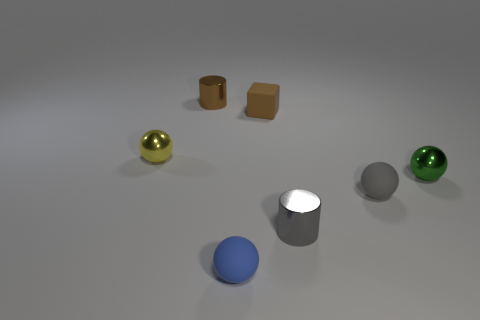Subtract all purple balls. Subtract all cyan blocks. How many balls are left? 4 Add 1 small gray objects. How many objects exist? 8 Subtract all spheres. How many objects are left? 3 Subtract all gray rubber objects. Subtract all small metallic blocks. How many objects are left? 6 Add 4 tiny gray matte spheres. How many tiny gray matte spheres are left? 5 Add 1 large red shiny cubes. How many large red shiny cubes exist? 1 Subtract 1 green balls. How many objects are left? 6 